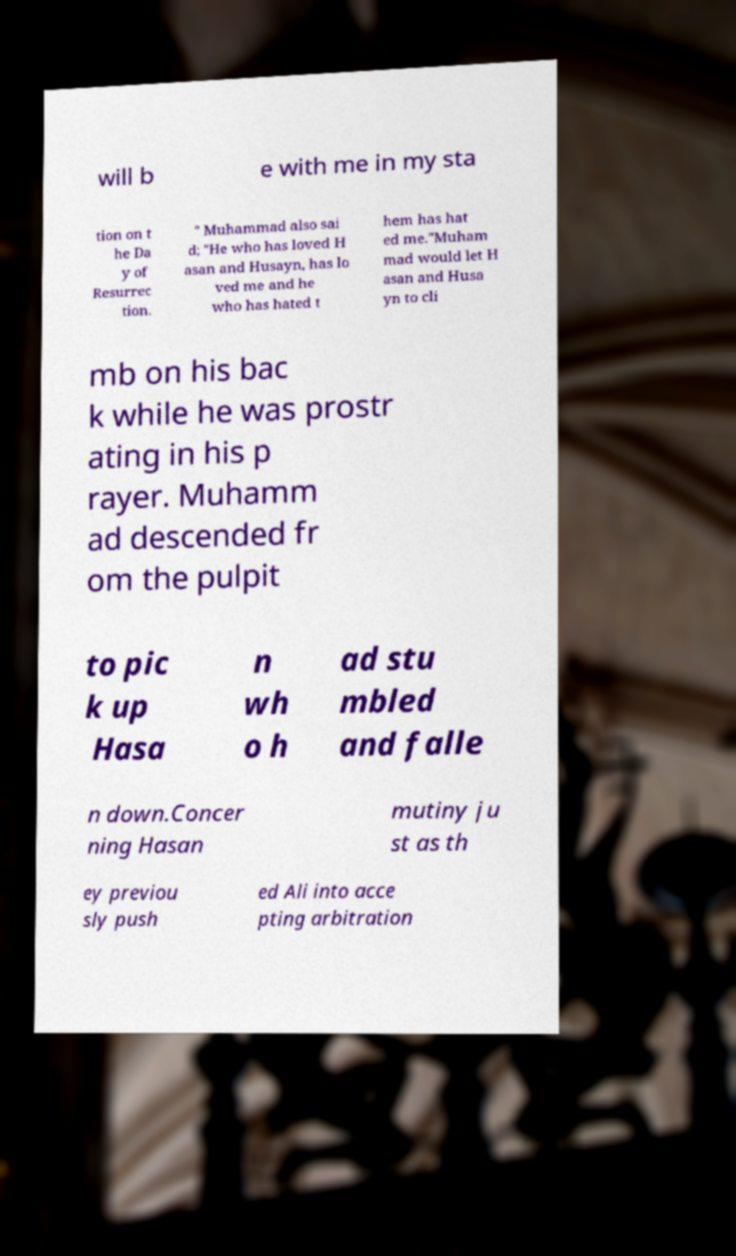Please identify and transcribe the text found in this image. will b e with me in my sta tion on t he Da y of Resurrec tion. " Muhammad also sai d; "He who has loved H asan and Husayn, has lo ved me and he who has hated t hem has hat ed me."Muham mad would let H asan and Husa yn to cli mb on his bac k while he was prostr ating in his p rayer. Muhamm ad descended fr om the pulpit to pic k up Hasa n wh o h ad stu mbled and falle n down.Concer ning Hasan mutiny ju st as th ey previou sly push ed Ali into acce pting arbitration 